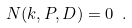<formula> <loc_0><loc_0><loc_500><loc_500>N ( k , P , D ) = 0 \ .</formula> 